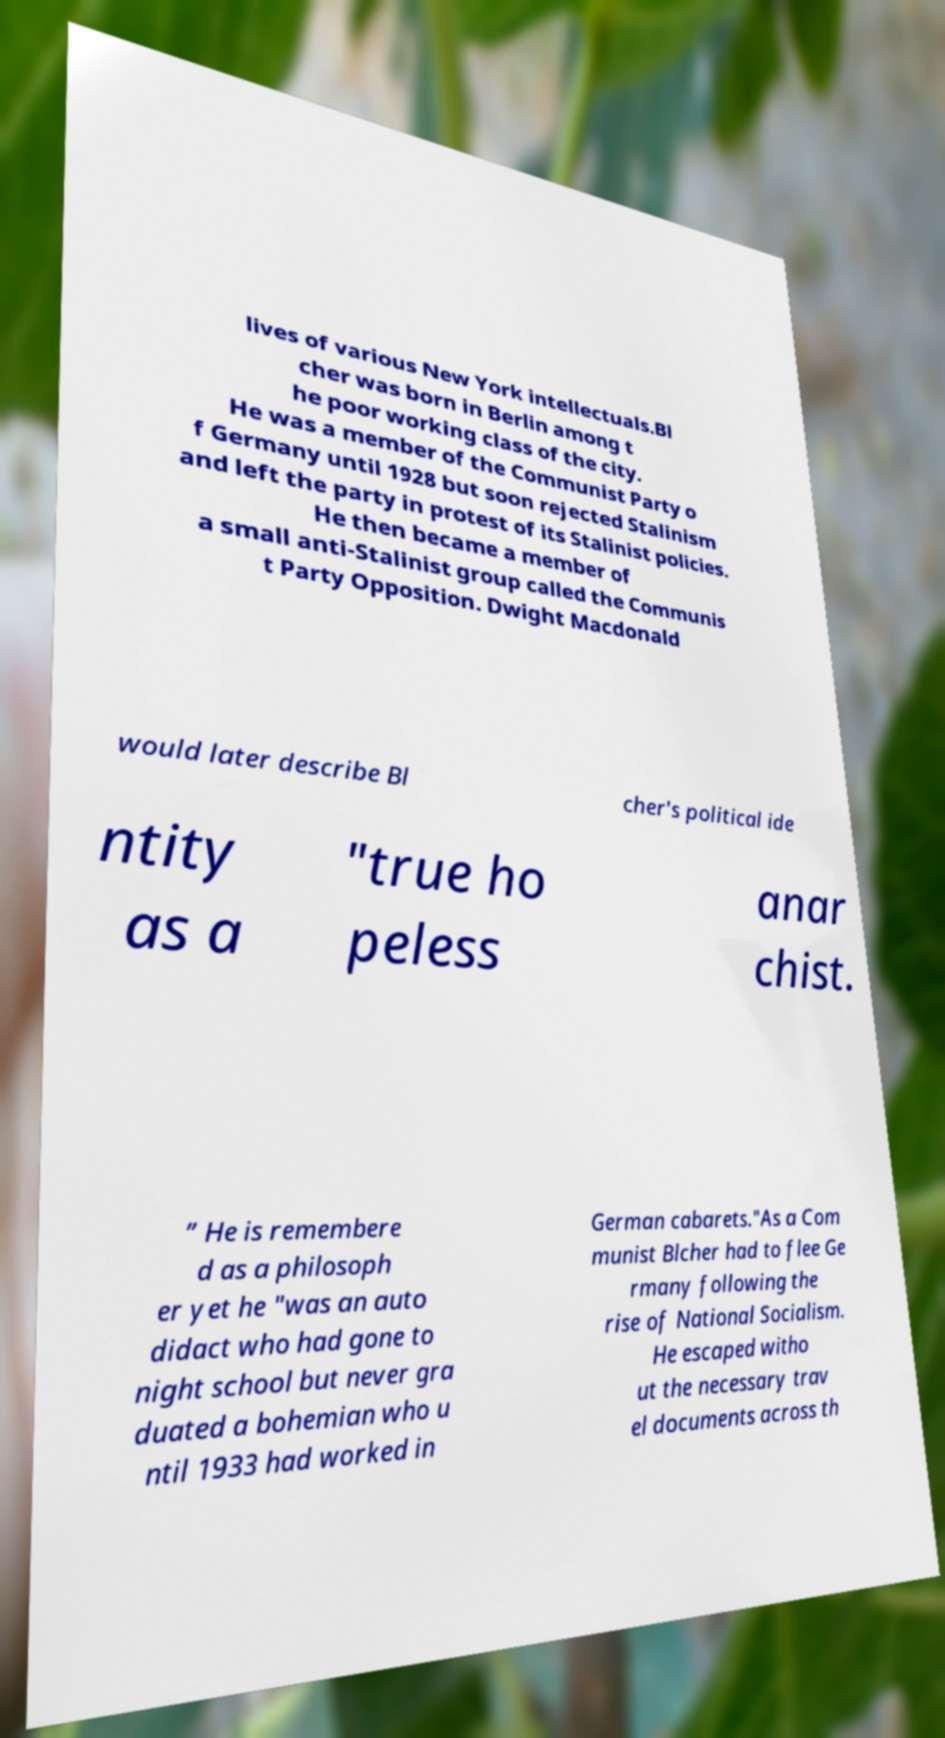Can you accurately transcribe the text from the provided image for me? lives of various New York intellectuals.Bl cher was born in Berlin among t he poor working class of the city. He was a member of the Communist Party o f Germany until 1928 but soon rejected Stalinism and left the party in protest of its Stalinist policies. He then became a member of a small anti-Stalinist group called the Communis t Party Opposition. Dwight Macdonald would later describe Bl cher's political ide ntity as a "true ho peless anar chist. ” He is remembere d as a philosoph er yet he "was an auto didact who had gone to night school but never gra duated a bohemian who u ntil 1933 had worked in German cabarets."As a Com munist Blcher had to flee Ge rmany following the rise of National Socialism. He escaped witho ut the necessary trav el documents across th 